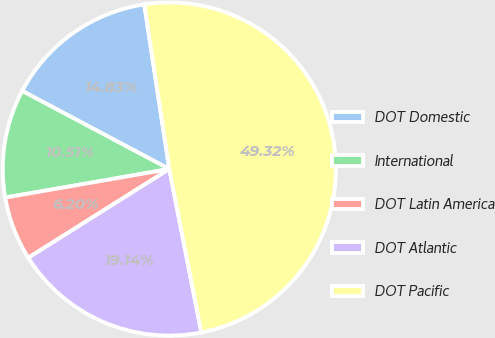<chart> <loc_0><loc_0><loc_500><loc_500><pie_chart><fcel>DOT Domestic<fcel>International<fcel>DOT Latin America<fcel>DOT Atlantic<fcel>DOT Pacific<nl><fcel>14.83%<fcel>10.51%<fcel>6.2%<fcel>19.14%<fcel>49.32%<nl></chart> 